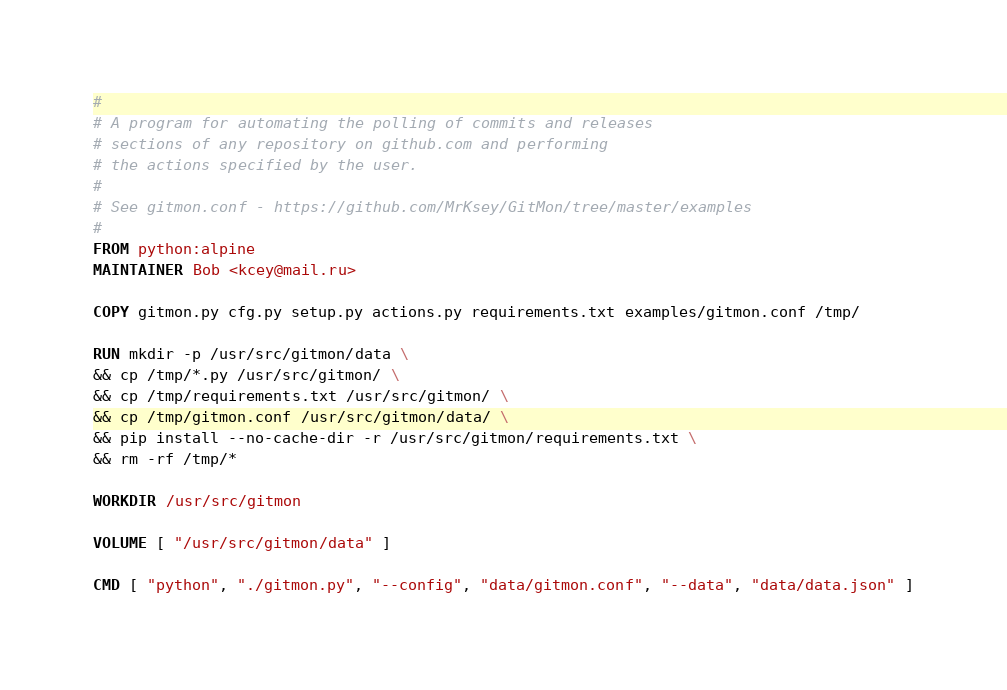Convert code to text. <code><loc_0><loc_0><loc_500><loc_500><_Dockerfile_>#
# A program for automating the polling of commits and releases
# sections of any repository on github.com and performing
# the actions specified by the user.
#
# See gitmon.conf - https://github.com/MrKsey/GitMon/tree/master/examples
#
FROM python:alpine
MAINTAINER Bob <kcey@mail.ru>

COPY gitmon.py cfg.py setup.py actions.py requirements.txt examples/gitmon.conf /tmp/

RUN mkdir -p /usr/src/gitmon/data \
&& cp /tmp/*.py /usr/src/gitmon/ \
&& cp /tmp/requirements.txt /usr/src/gitmon/ \
&& cp /tmp/gitmon.conf /usr/src/gitmon/data/ \
&& pip install --no-cache-dir -r /usr/src/gitmon/requirements.txt \
&& rm -rf /tmp/*

WORKDIR /usr/src/gitmon

VOLUME [ "/usr/src/gitmon/data" ]

CMD [ "python", "./gitmon.py", "--config", "data/gitmon.conf", "--data", "data/data.json" ]
</code> 